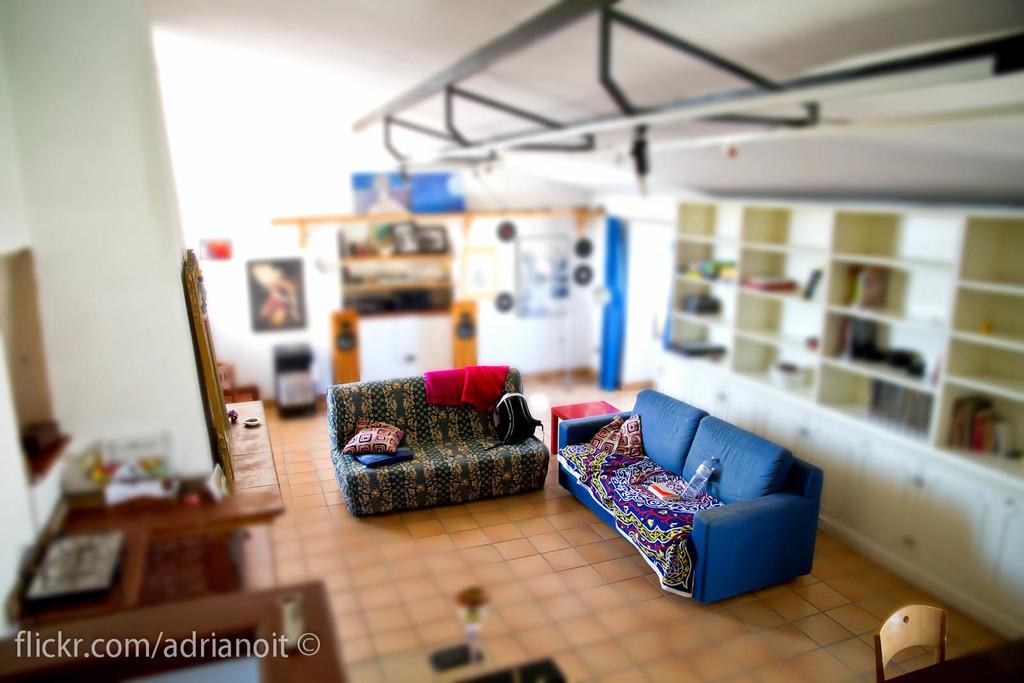<image>
Give a short and clear explanation of the subsequent image. A photo of a living room from the Flickr account Adrinoit 